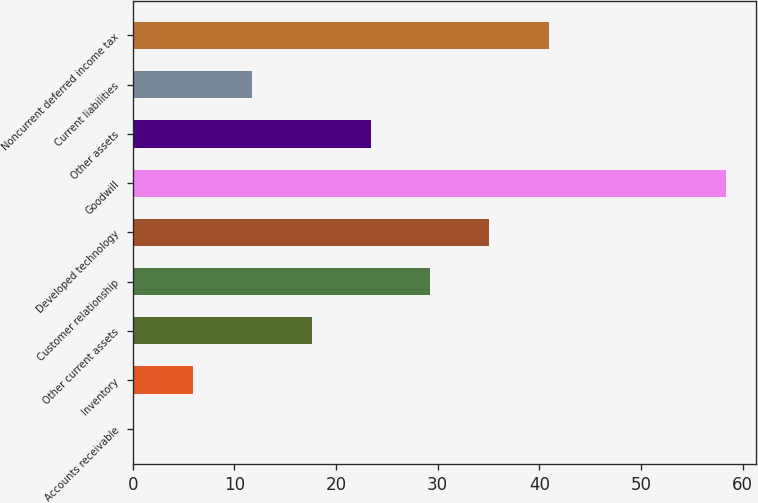<chart> <loc_0><loc_0><loc_500><loc_500><bar_chart><fcel>Accounts receivable<fcel>Inventory<fcel>Other current assets<fcel>Customer relationship<fcel>Developed technology<fcel>Goodwill<fcel>Other assets<fcel>Current liabilities<fcel>Noncurrent deferred income tax<nl><fcel>0.1<fcel>5.93<fcel>17.59<fcel>29.25<fcel>35.08<fcel>58.4<fcel>23.42<fcel>11.76<fcel>40.91<nl></chart> 